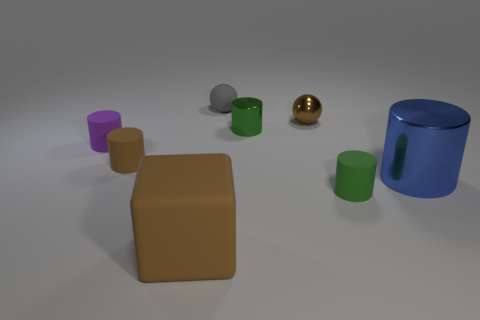What size is the rubber cylinder that is the same color as the tiny metallic cylinder?
Ensure brevity in your answer.  Small. There is a tiny object that is the same color as the metallic ball; what material is it?
Offer a very short reply. Rubber. What is the shape of the small object that is to the left of the tiny metal cylinder and behind the purple rubber object?
Provide a succinct answer. Sphere. There is a brown block that is left of the cylinder that is behind the purple rubber cylinder; what number of big metal things are in front of it?
Make the answer very short. 0. What size is the brown metallic object that is the same shape as the gray thing?
Give a very brief answer. Small. Is there anything else that has the same size as the brown shiny ball?
Offer a terse response. Yes. Is the material of the small green object behind the tiny purple matte cylinder the same as the small purple object?
Your answer should be compact. No. There is a tiny metal thing that is the same shape as the tiny green rubber thing; what is its color?
Give a very brief answer. Green. What number of other things are there of the same color as the big matte cube?
Give a very brief answer. 2. There is a tiny object that is behind the small shiny ball; does it have the same shape as the brown thing on the right side of the green shiny object?
Your response must be concise. Yes. 